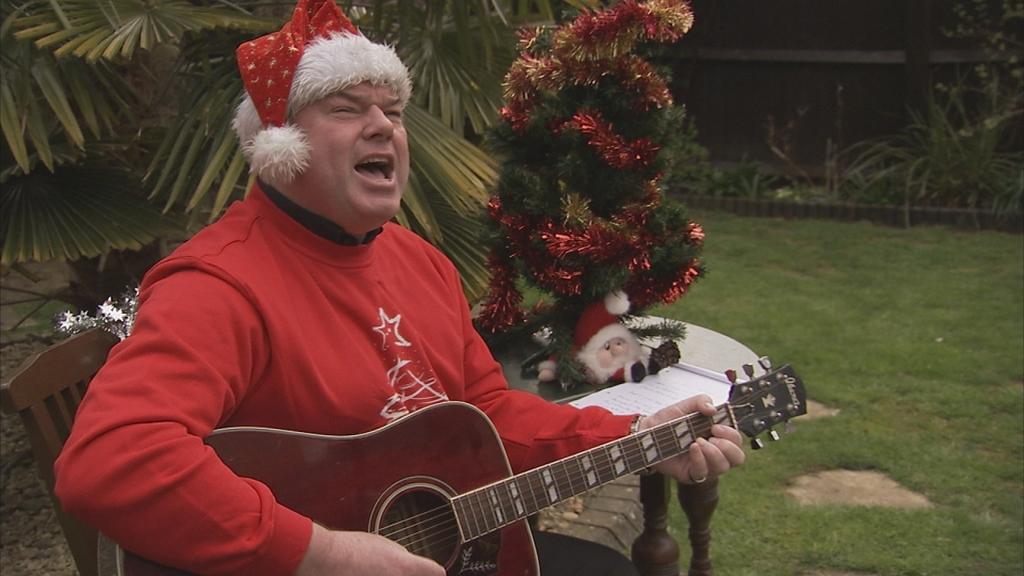Can you describe this image briefly? a person is sitting on a wooden chairs and playing guitar. he is wearing a red t shirt and a Christmas hat. behind him there is a tree, a Santa Claus toy and a book on a white table. they are present on the grass. behind them there are plants. 